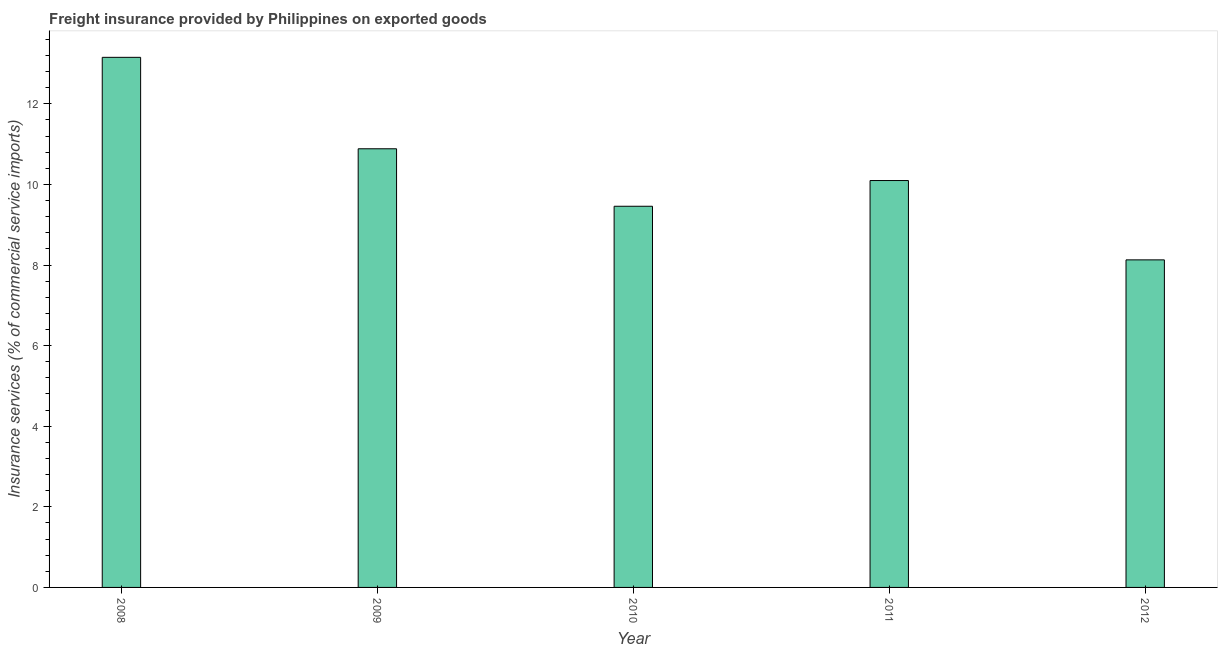Does the graph contain grids?
Ensure brevity in your answer.  No. What is the title of the graph?
Ensure brevity in your answer.  Freight insurance provided by Philippines on exported goods . What is the label or title of the X-axis?
Your response must be concise. Year. What is the label or title of the Y-axis?
Your response must be concise. Insurance services (% of commercial service imports). What is the freight insurance in 2011?
Offer a very short reply. 10.1. Across all years, what is the maximum freight insurance?
Your answer should be very brief. 13.15. Across all years, what is the minimum freight insurance?
Offer a very short reply. 8.13. In which year was the freight insurance maximum?
Ensure brevity in your answer.  2008. In which year was the freight insurance minimum?
Offer a very short reply. 2012. What is the sum of the freight insurance?
Offer a terse response. 51.72. What is the difference between the freight insurance in 2010 and 2011?
Ensure brevity in your answer.  -0.64. What is the average freight insurance per year?
Offer a terse response. 10.34. What is the median freight insurance?
Provide a short and direct response. 10.1. What is the ratio of the freight insurance in 2008 to that in 2012?
Offer a terse response. 1.62. Is the freight insurance in 2008 less than that in 2011?
Make the answer very short. No. What is the difference between the highest and the second highest freight insurance?
Offer a very short reply. 2.27. What is the difference between the highest and the lowest freight insurance?
Your response must be concise. 5.03. In how many years, is the freight insurance greater than the average freight insurance taken over all years?
Your response must be concise. 2. How many bars are there?
Your answer should be compact. 5. How many years are there in the graph?
Offer a terse response. 5. What is the Insurance services (% of commercial service imports) of 2008?
Provide a succinct answer. 13.15. What is the Insurance services (% of commercial service imports) in 2009?
Make the answer very short. 10.88. What is the Insurance services (% of commercial service imports) of 2010?
Your answer should be compact. 9.46. What is the Insurance services (% of commercial service imports) in 2011?
Your response must be concise. 10.1. What is the Insurance services (% of commercial service imports) of 2012?
Keep it short and to the point. 8.13. What is the difference between the Insurance services (% of commercial service imports) in 2008 and 2009?
Keep it short and to the point. 2.27. What is the difference between the Insurance services (% of commercial service imports) in 2008 and 2010?
Provide a short and direct response. 3.7. What is the difference between the Insurance services (% of commercial service imports) in 2008 and 2011?
Give a very brief answer. 3.06. What is the difference between the Insurance services (% of commercial service imports) in 2008 and 2012?
Provide a short and direct response. 5.03. What is the difference between the Insurance services (% of commercial service imports) in 2009 and 2010?
Ensure brevity in your answer.  1.43. What is the difference between the Insurance services (% of commercial service imports) in 2009 and 2011?
Offer a terse response. 0.79. What is the difference between the Insurance services (% of commercial service imports) in 2009 and 2012?
Ensure brevity in your answer.  2.76. What is the difference between the Insurance services (% of commercial service imports) in 2010 and 2011?
Your response must be concise. -0.64. What is the difference between the Insurance services (% of commercial service imports) in 2010 and 2012?
Your response must be concise. 1.33. What is the difference between the Insurance services (% of commercial service imports) in 2011 and 2012?
Give a very brief answer. 1.97. What is the ratio of the Insurance services (% of commercial service imports) in 2008 to that in 2009?
Make the answer very short. 1.21. What is the ratio of the Insurance services (% of commercial service imports) in 2008 to that in 2010?
Keep it short and to the point. 1.39. What is the ratio of the Insurance services (% of commercial service imports) in 2008 to that in 2011?
Your answer should be very brief. 1.3. What is the ratio of the Insurance services (% of commercial service imports) in 2008 to that in 2012?
Give a very brief answer. 1.62. What is the ratio of the Insurance services (% of commercial service imports) in 2009 to that in 2010?
Ensure brevity in your answer.  1.15. What is the ratio of the Insurance services (% of commercial service imports) in 2009 to that in 2011?
Your answer should be compact. 1.08. What is the ratio of the Insurance services (% of commercial service imports) in 2009 to that in 2012?
Give a very brief answer. 1.34. What is the ratio of the Insurance services (% of commercial service imports) in 2010 to that in 2011?
Your response must be concise. 0.94. What is the ratio of the Insurance services (% of commercial service imports) in 2010 to that in 2012?
Ensure brevity in your answer.  1.16. What is the ratio of the Insurance services (% of commercial service imports) in 2011 to that in 2012?
Provide a succinct answer. 1.24. 